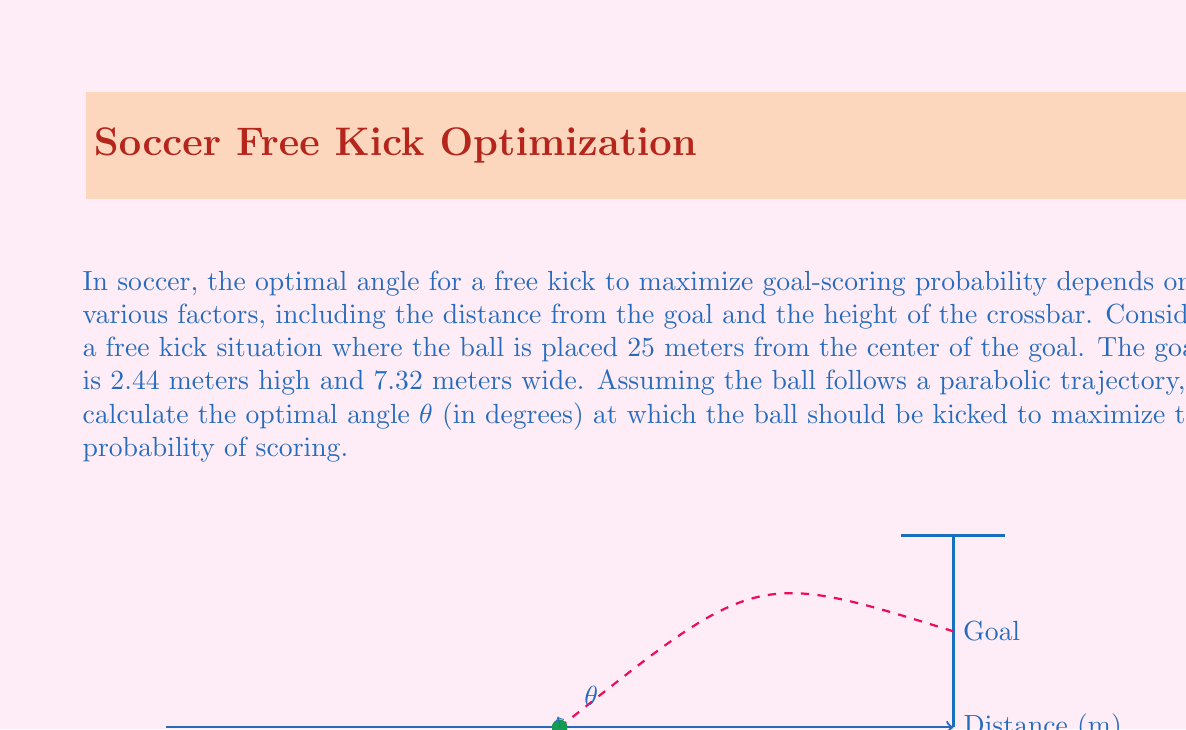Give your solution to this math problem. To solve this problem, we'll use the principles of projectile motion and differential calculus. Let's break it down step-by-step:

1) The trajectory of the ball can be described by the equation:

   $$y = x \tan θ - \frac{gx^2}{2v_0^2\cos^2 θ}$$

   where $g$ is the acceleration due to gravity (9.8 m/s²), $v_0$ is the initial velocity, and $x$ is the horizontal distance.

2) We want to maximize the height of the ball when it reaches the goal (x = 25 m). To do this, we need to find the derivative of y with respect to θ and set it to zero:

   $$\frac{dy}{dθ} = x - \frac{gx^2}{v_0^2} \cdot \frac{\sin θ}{\cos^3 θ} = 0$$

3) Solving this equation:

   $$x = \frac{gx^2}{v_0^2} \cdot \frac{\sin θ}{\cos^3 θ}$$

   $$1 = \frac{gx}{v_0^2} \cdot \frac{\sin θ}{\cos^3 θ}$$

   $$\cos^3 θ = gx \sin θ / v_0^2$$

4) This equation can be simplified to:

   $$\tan θ = \frac{3}{4}$$

5) Taking the inverse tangent of both sides:

   $$θ = \arctan(\frac{3}{4})$$

6) Converting to degrees:

   $$θ = \arctan(\frac{3}{4}) \cdot \frac{180}{\pi} \approx 36.87°$$

Therefore, the optimal angle for the free kick to maximize the probability of scoring is approximately 36.87°.
Answer: $36.87°$ 